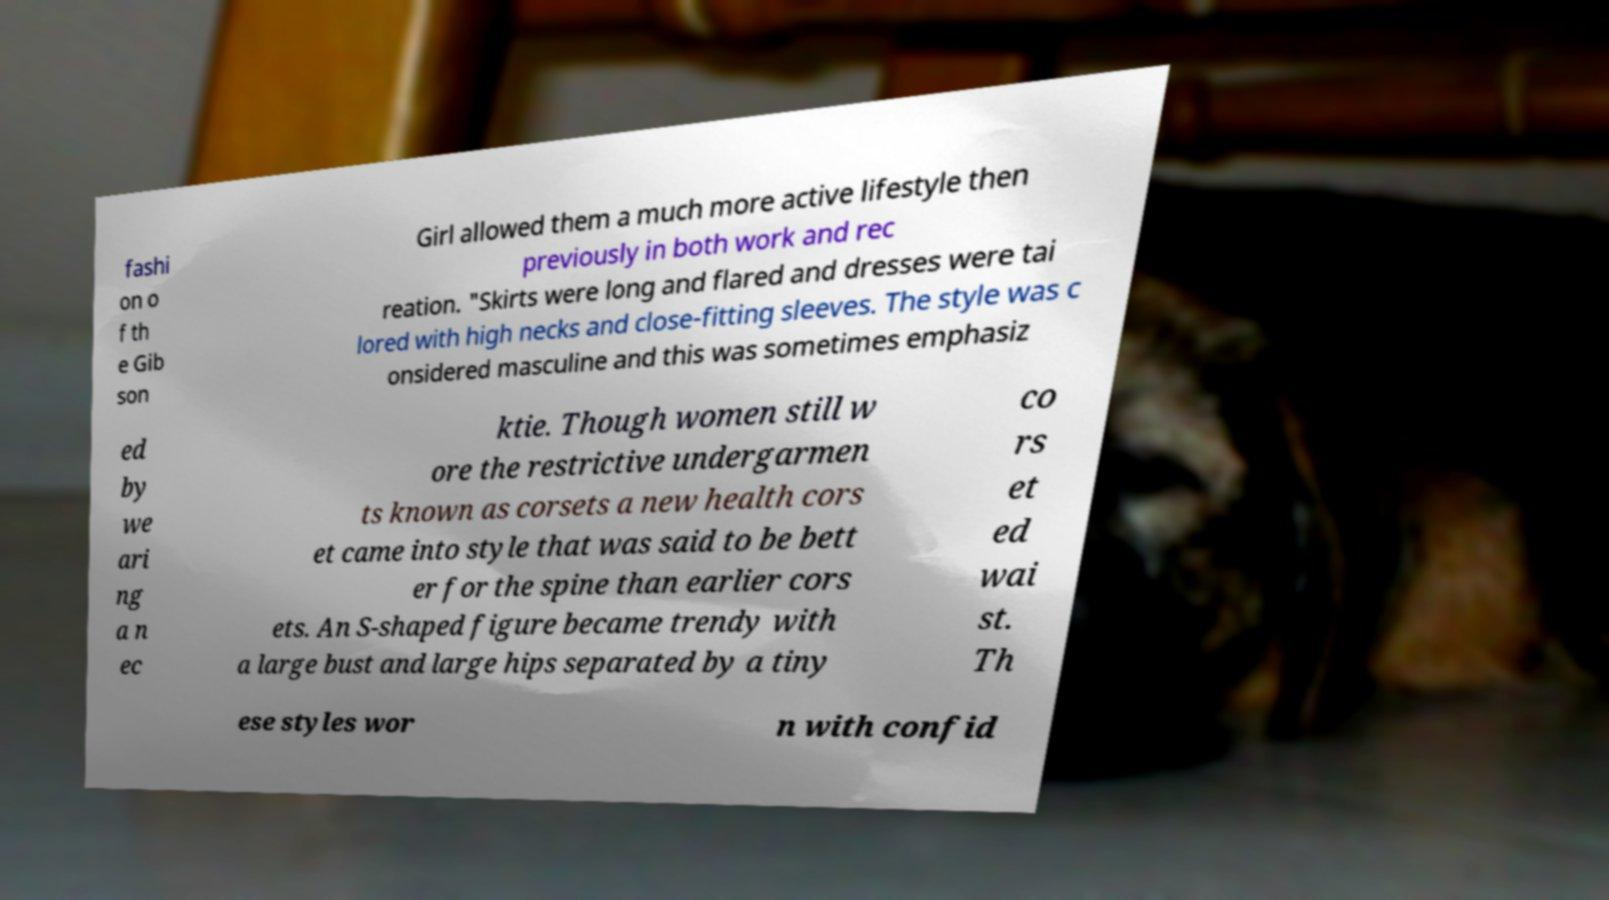I need the written content from this picture converted into text. Can you do that? fashi on o f th e Gib son Girl allowed them a much more active lifestyle then previously in both work and rec reation. "Skirts were long and flared and dresses were tai lored with high necks and close-fitting sleeves. The style was c onsidered masculine and this was sometimes emphasiz ed by we ari ng a n ec ktie. Though women still w ore the restrictive undergarmen ts known as corsets a new health cors et came into style that was said to be bett er for the spine than earlier cors ets. An S-shaped figure became trendy with a large bust and large hips separated by a tiny co rs et ed wai st. Th ese styles wor n with confid 